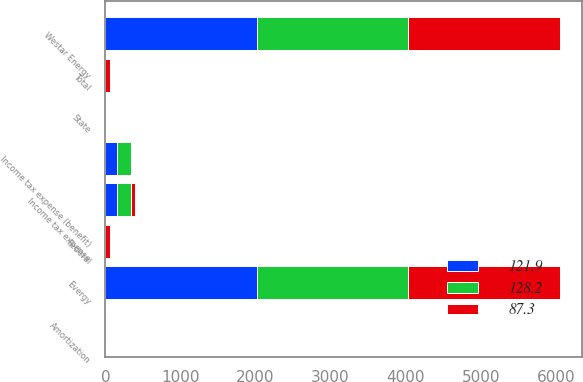<chart> <loc_0><loc_0><loc_500><loc_500><stacked_bar_chart><ecel><fcel>Evergy<fcel>Federal<fcel>State<fcel>Total<fcel>Amortization<fcel>Income tax expense<fcel>Westar Energy<fcel>Income tax expense (benefit)<nl><fcel>87.3<fcel>2018<fcel>67.4<fcel>2.2<fcel>65.2<fcel>3.6<fcel>59<fcel>2018<fcel>4.3<nl><fcel>121.9<fcel>2017<fcel>0.1<fcel>0.4<fcel>0.5<fcel>2.8<fcel>151.2<fcel>2017<fcel>151.2<nl><fcel>128.2<fcel>2016<fcel>1<fcel>0.3<fcel>0.7<fcel>2.9<fcel>184.5<fcel>2016<fcel>184.5<nl></chart> 